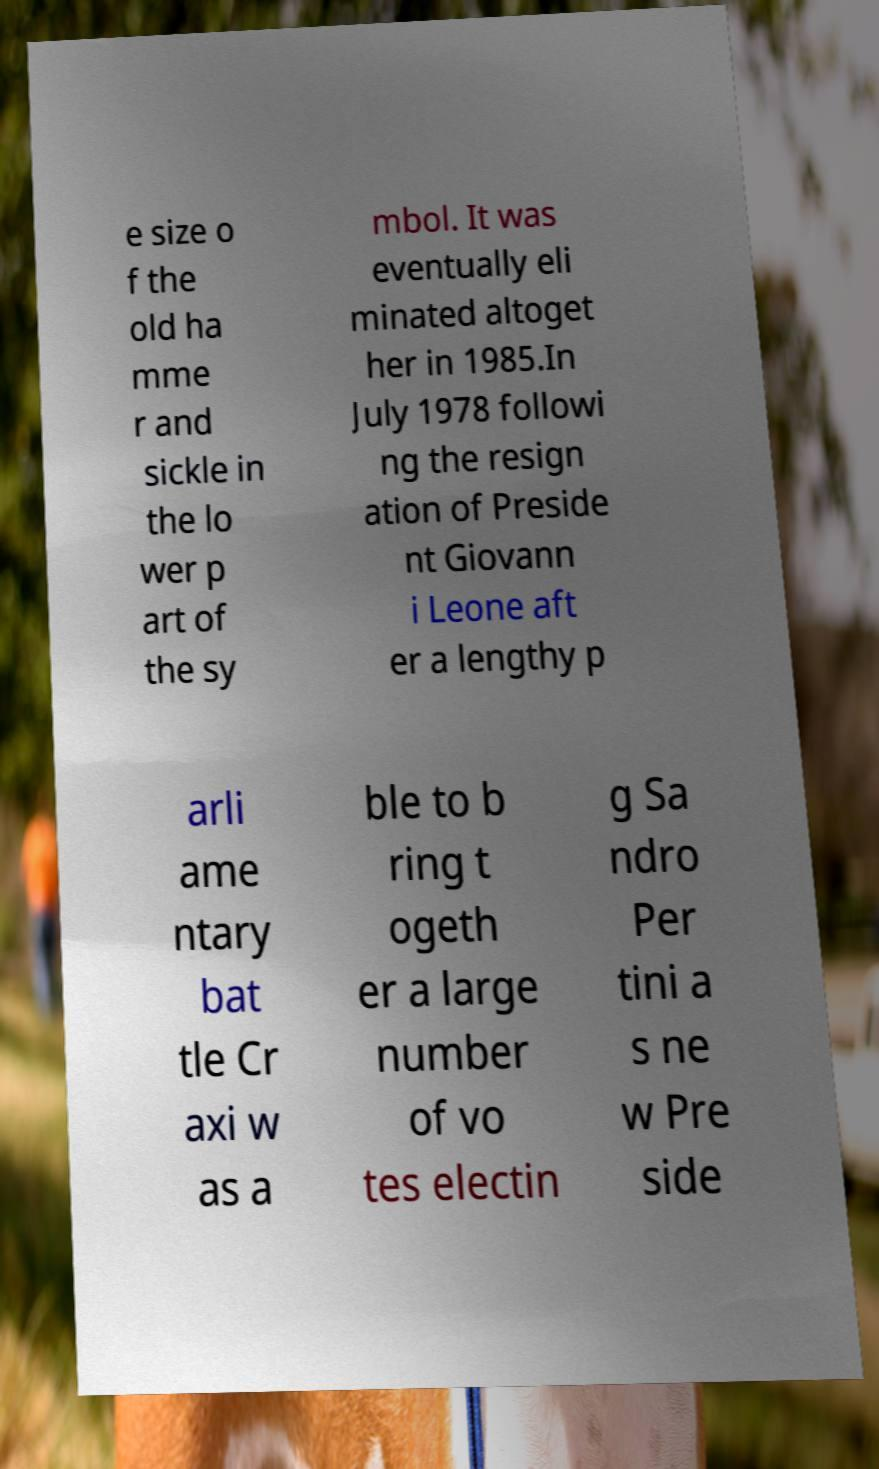Could you extract and type out the text from this image? e size o f the old ha mme r and sickle in the lo wer p art of the sy mbol. It was eventually eli minated altoget her in 1985.In July 1978 followi ng the resign ation of Preside nt Giovann i Leone aft er a lengthy p arli ame ntary bat tle Cr axi w as a ble to b ring t ogeth er a large number of vo tes electin g Sa ndro Per tini a s ne w Pre side 